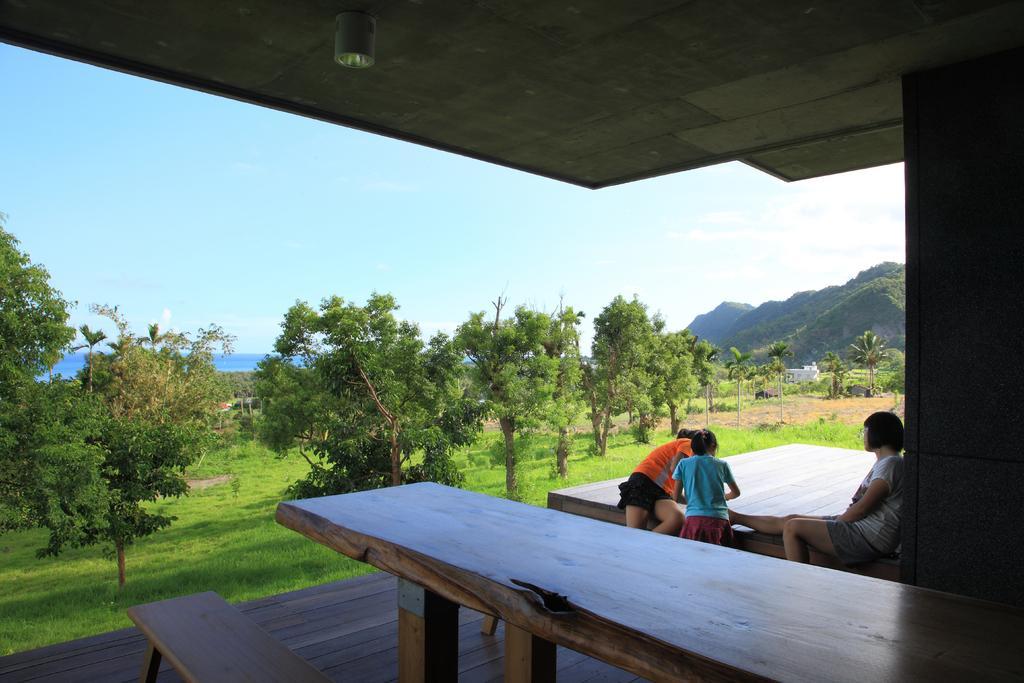Could you give a brief overview of what you see in this image? In this picture we can see two girls and one woman sitting on bench and this girl is standing and beside to her we can have wooden table, bench and in background we can see sky, trees, mountains. 